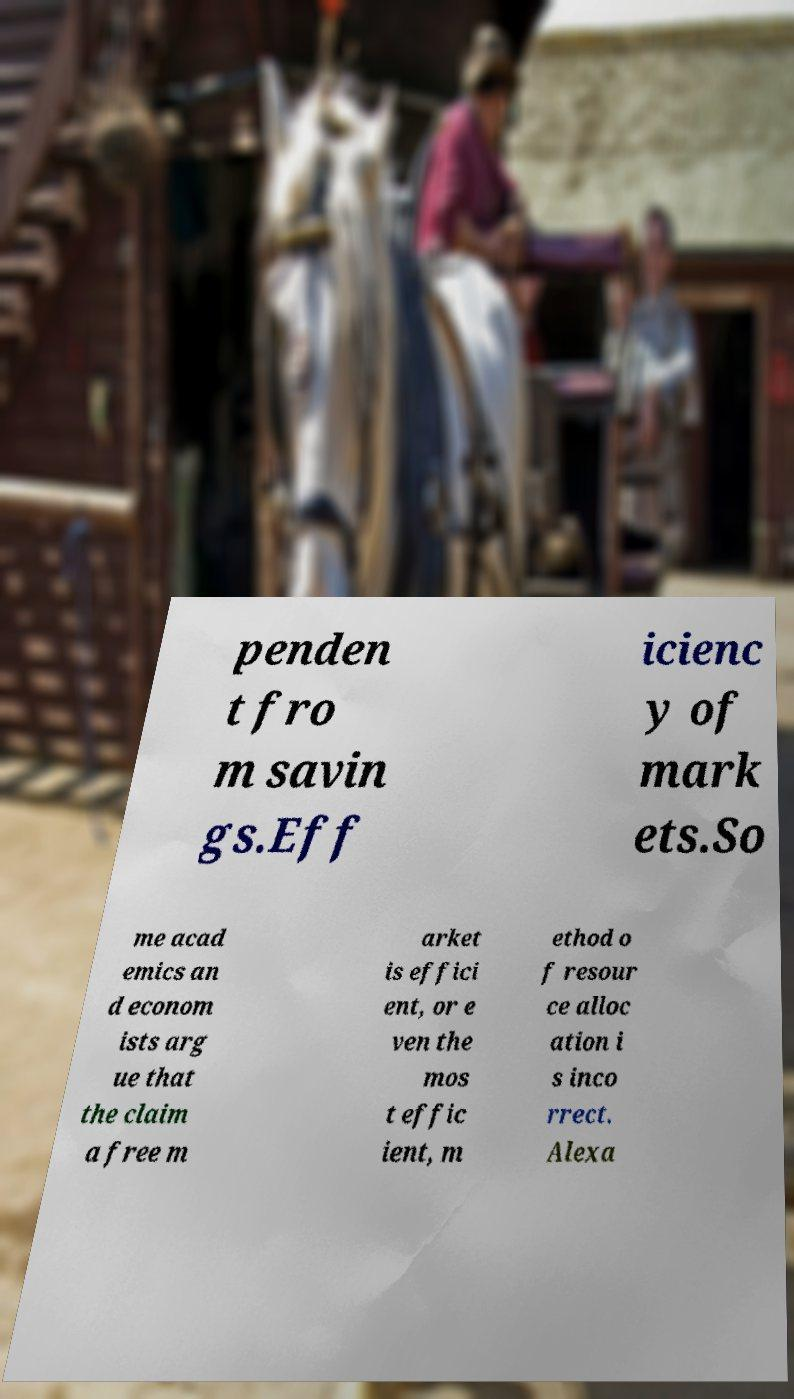For documentation purposes, I need the text within this image transcribed. Could you provide that? penden t fro m savin gs.Eff icienc y of mark ets.So me acad emics an d econom ists arg ue that the claim a free m arket is effici ent, or e ven the mos t effic ient, m ethod o f resour ce alloc ation i s inco rrect. Alexa 